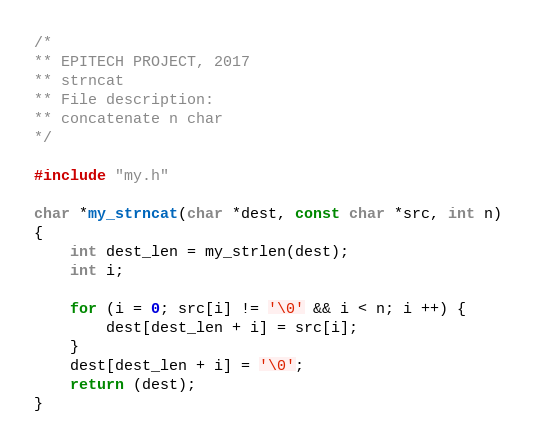<code> <loc_0><loc_0><loc_500><loc_500><_C_>/*
** EPITECH PROJECT, 2017
** strncat
** File description:
** concatenate n char
*/

#include "my.h"

char *my_strncat(char *dest, const char *src, int n)
{
	int dest_len = my_strlen(dest);
	int i;

	for (i = 0; src[i] != '\0' && i < n; i ++) {
		dest[dest_len + i] = src[i];
	}
	dest[dest_len + i] = '\0';
	return (dest);
}
</code> 